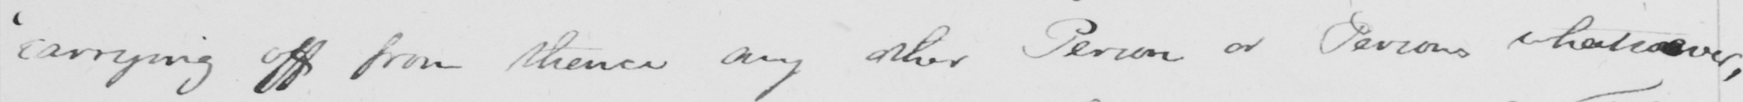Please provide the text content of this handwritten line. ' carrying off from thence any other Person or Persons whatsoever , 